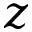<formula> <loc_0><loc_0><loc_500><loc_500>z</formula> 